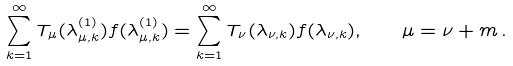<formula> <loc_0><loc_0><loc_500><loc_500>\sum _ { k = 1 } ^ { \infty } T _ { \mu } ( \lambda _ { \mu , k } ^ { ( 1 ) } ) f ( \lambda _ { \mu , k } ^ { ( 1 ) } ) = \sum _ { k = 1 } ^ { \infty } T _ { \nu } ( \lambda _ { \nu , k } ) f ( \lambda _ { \nu , k } ) , \quad \mu = \nu + m \, .</formula> 